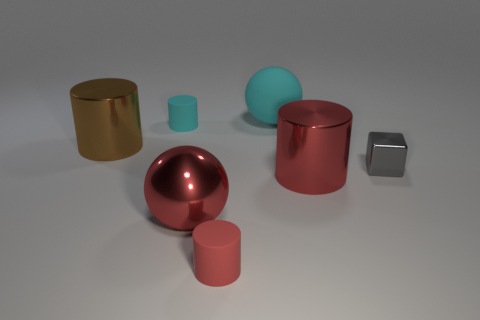Subtract 1 cylinders. How many cylinders are left? 3 Add 2 gray cylinders. How many objects exist? 9 Subtract all cubes. How many objects are left? 6 Subtract 0 cyan cubes. How many objects are left? 7 Subtract all tiny gray objects. Subtract all cyan spheres. How many objects are left? 5 Add 7 tiny metal objects. How many tiny metal objects are left? 8 Add 2 big red rubber cubes. How many big red rubber cubes exist? 2 